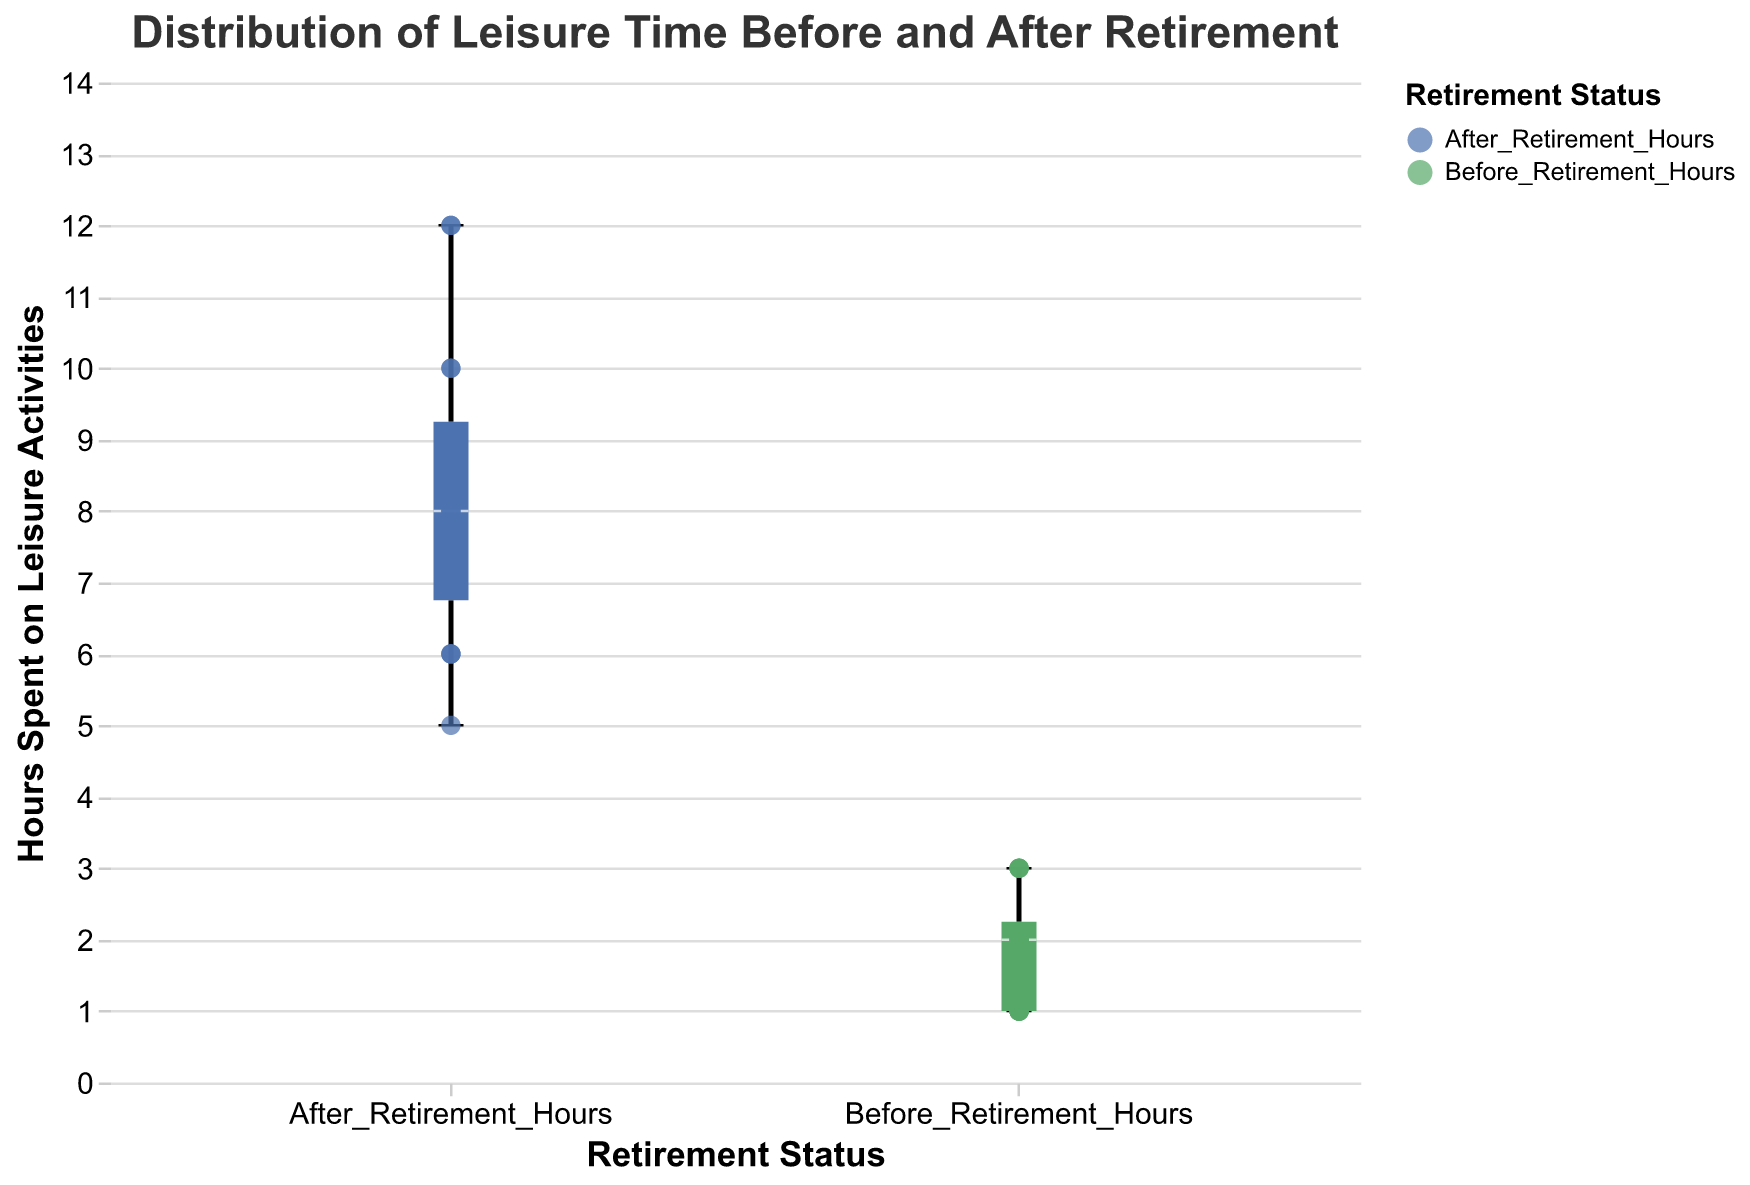How many veterans are shown in the figure? Count the number of unique data points (or dots) shown in the plot for both "Before Retirement" and "After Retirement". There are 16 veterans listed in the data.
Answer: 16 What is the title of the figure? Read the title displayed at the top of the figure. It is "Distribution of Leisure Time Before and After Retirement".
Answer: Distribution of Leisure Time Before and After Retirement Which leisure activity does Alice Brown spend 12 hours on after retirement? Hover over the data point for "After Retirement" and find Alice Brown's entry. The tooltip shows she spends 12 hours on "Golfing".
Answer: Golfing Which retirement status has the higher median value for leisure hours? Look at the boxplot's median line (inside the box) for both "Before Retirement" and "After Retirement". The "After Retirement" group has a higher median value.
Answer: After Retirement What is the minimum number of hours spent on leisure activities by any veteran after retirement? Identify the lower whisker (bottom line) of the "After Retirement" boxplot. It represents the minimum value, which is 5 hours.
Answer: 5 What is the median number of hours spent on leisure activities before retirement? Observe the line that crosses the box in the "Before Retirement" boxplot as it represents the median. The median hours before retirement is around 2 hours.
Answer: 2 What is the interquartile range (IQR) for leisure hours after retirement? The IQR is the range between the first quartile (bottom of the box) and the third quartile (top of the box). For "After Retirement", the first quartile is approximately 7 hours, and the third quartile is about 10 hours. Therefore, the IQR is 10 - 7 = 3 hours.
Answer: 3 Which veteran spends the most time on traveling after retirement and how many hours do they spend? Hover over the scatter points for "After Retirement". Linda Martinez is identified as the veteran who spends the most time on traveling, which is 12 hours.
Answer: Linda Martinez, 12 hours How much more time does Robert Harris spend cycling after retirement compared to before retirement? Check Robert Harris's data points for "Before Retirement" and "After Retirement". He spends 3 hours before and 7 hours after retirement on cycling. The difference is 7 - 3 = 4 hours.
Answer: 4 hours What is the range of hours spent on leisure activities before retirement? Identify the minimum and maximum values (ends of the whiskers) in the "Before Retirement" boxplot, which are 1 hour and 3 hours respectively. The range is 3 - 1 = 2 hours.
Answer: 2 hours 